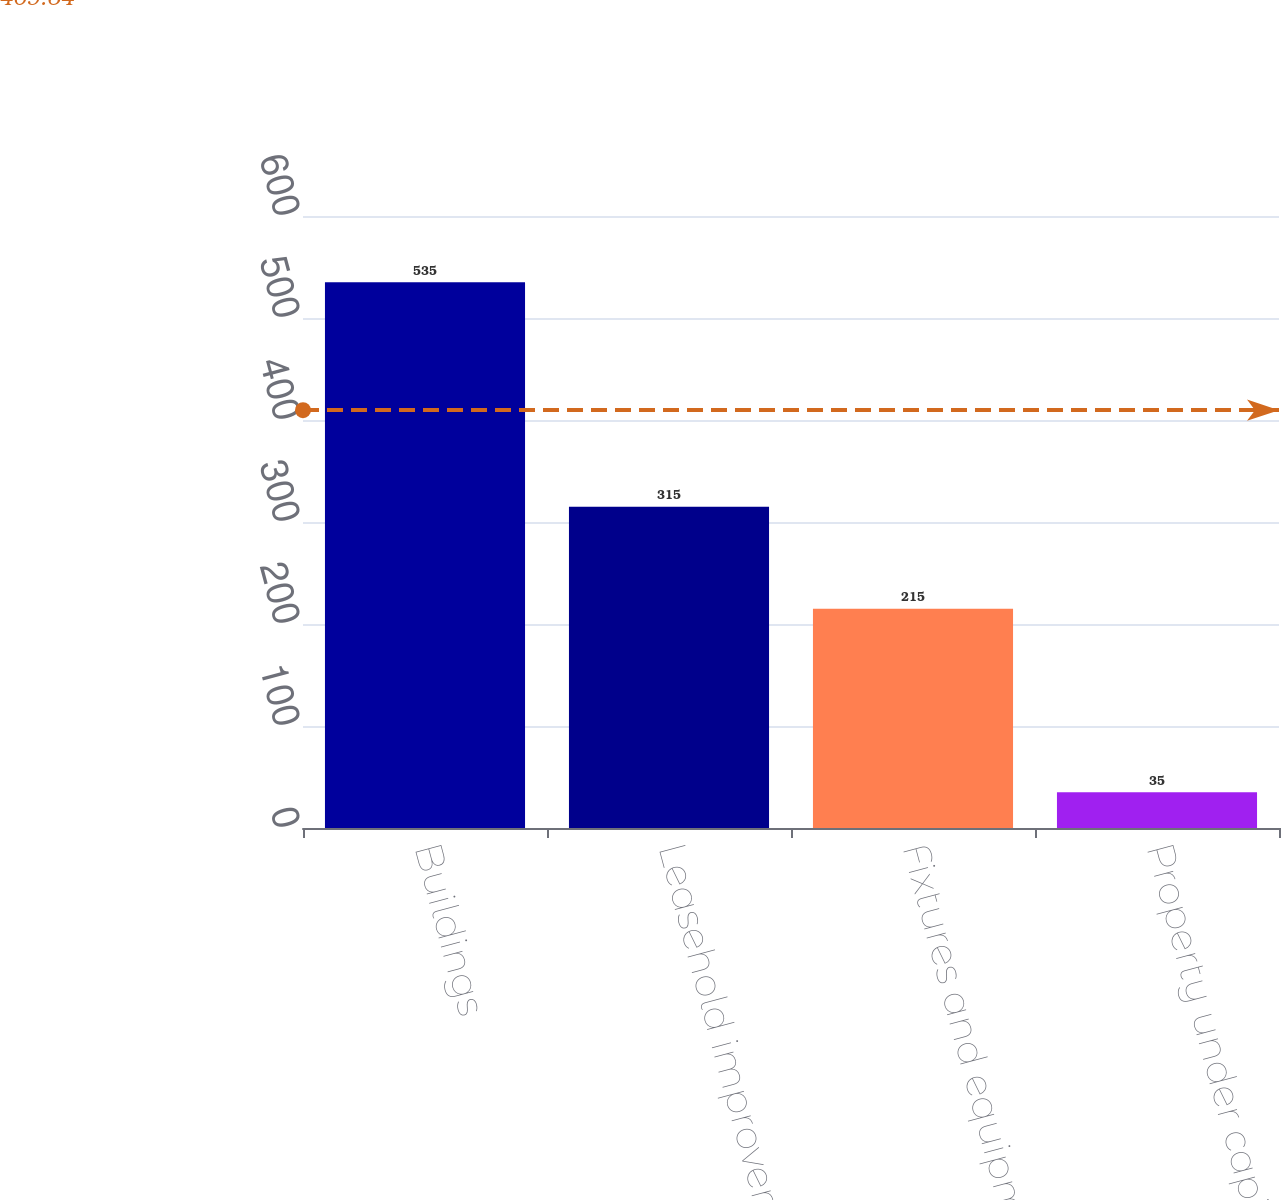Convert chart. <chart><loc_0><loc_0><loc_500><loc_500><bar_chart><fcel>Buildings<fcel>Leasehold improvements<fcel>Fixtures and equipment<fcel>Property under capital and<nl><fcel>535<fcel>315<fcel>215<fcel>35<nl></chart> 